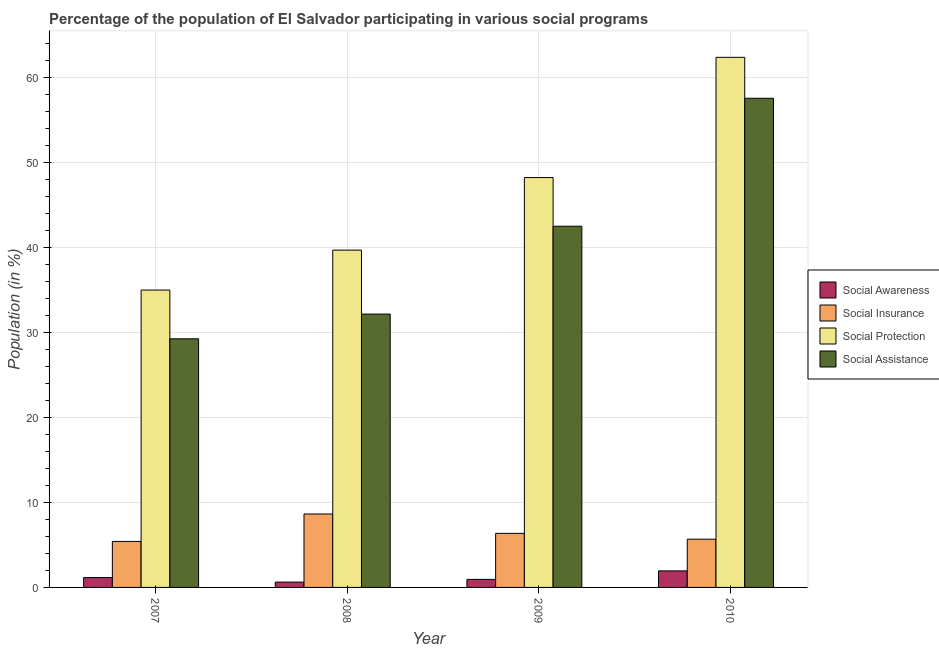How many different coloured bars are there?
Give a very brief answer. 4. How many groups of bars are there?
Give a very brief answer. 4. Are the number of bars per tick equal to the number of legend labels?
Provide a short and direct response. Yes. Are the number of bars on each tick of the X-axis equal?
Your answer should be very brief. Yes. In how many cases, is the number of bars for a given year not equal to the number of legend labels?
Your answer should be very brief. 0. What is the participation of population in social insurance programs in 2008?
Your response must be concise. 8.63. Across all years, what is the maximum participation of population in social protection programs?
Your answer should be compact. 62.34. Across all years, what is the minimum participation of population in social awareness programs?
Offer a very short reply. 0.63. In which year was the participation of population in social insurance programs maximum?
Your response must be concise. 2008. In which year was the participation of population in social insurance programs minimum?
Provide a succinct answer. 2007. What is the total participation of population in social insurance programs in the graph?
Give a very brief answer. 26.07. What is the difference between the participation of population in social insurance programs in 2007 and that in 2010?
Your answer should be very brief. -0.26. What is the difference between the participation of population in social assistance programs in 2009 and the participation of population in social insurance programs in 2007?
Provide a succinct answer. 13.24. What is the average participation of population in social awareness programs per year?
Your response must be concise. 1.17. In the year 2008, what is the difference between the participation of population in social protection programs and participation of population in social awareness programs?
Keep it short and to the point. 0. In how many years, is the participation of population in social protection programs greater than 44 %?
Ensure brevity in your answer.  2. What is the ratio of the participation of population in social protection programs in 2007 to that in 2008?
Ensure brevity in your answer.  0.88. What is the difference between the highest and the second highest participation of population in social awareness programs?
Provide a succinct answer. 0.79. What is the difference between the highest and the lowest participation of population in social awareness programs?
Provide a short and direct response. 1.32. In how many years, is the participation of population in social awareness programs greater than the average participation of population in social awareness programs taken over all years?
Provide a short and direct response. 1. Is the sum of the participation of population in social protection programs in 2008 and 2010 greater than the maximum participation of population in social insurance programs across all years?
Provide a succinct answer. Yes. Is it the case that in every year, the sum of the participation of population in social insurance programs and participation of population in social awareness programs is greater than the sum of participation of population in social protection programs and participation of population in social assistance programs?
Keep it short and to the point. No. What does the 4th bar from the left in 2007 represents?
Ensure brevity in your answer.  Social Assistance. What does the 1st bar from the right in 2007 represents?
Make the answer very short. Social Assistance. Are all the bars in the graph horizontal?
Offer a very short reply. No. How many years are there in the graph?
Keep it short and to the point. 4. What is the difference between two consecutive major ticks on the Y-axis?
Provide a short and direct response. 10. Are the values on the major ticks of Y-axis written in scientific E-notation?
Keep it short and to the point. No. Where does the legend appear in the graph?
Give a very brief answer. Center right. How many legend labels are there?
Keep it short and to the point. 4. How are the legend labels stacked?
Offer a terse response. Vertical. What is the title of the graph?
Your answer should be compact. Percentage of the population of El Salvador participating in various social programs . What is the label or title of the X-axis?
Give a very brief answer. Year. What is the Population (in %) of Social Awareness in 2007?
Your answer should be compact. 1.16. What is the Population (in %) of Social Insurance in 2007?
Make the answer very short. 5.41. What is the Population (in %) in Social Protection in 2007?
Ensure brevity in your answer.  34.97. What is the Population (in %) of Social Assistance in 2007?
Keep it short and to the point. 29.24. What is the Population (in %) in Social Awareness in 2008?
Your response must be concise. 0.63. What is the Population (in %) in Social Insurance in 2008?
Give a very brief answer. 8.63. What is the Population (in %) in Social Protection in 2008?
Provide a short and direct response. 39.67. What is the Population (in %) in Social Assistance in 2008?
Offer a very short reply. 32.15. What is the Population (in %) in Social Awareness in 2009?
Your answer should be compact. 0.95. What is the Population (in %) in Social Insurance in 2009?
Your answer should be compact. 6.36. What is the Population (in %) of Social Protection in 2009?
Provide a short and direct response. 48.2. What is the Population (in %) of Social Assistance in 2009?
Give a very brief answer. 42.48. What is the Population (in %) of Social Awareness in 2010?
Your answer should be very brief. 1.95. What is the Population (in %) in Social Insurance in 2010?
Make the answer very short. 5.67. What is the Population (in %) in Social Protection in 2010?
Provide a succinct answer. 62.34. What is the Population (in %) of Social Assistance in 2010?
Ensure brevity in your answer.  57.53. Across all years, what is the maximum Population (in %) in Social Awareness?
Make the answer very short. 1.95. Across all years, what is the maximum Population (in %) in Social Insurance?
Provide a succinct answer. 8.63. Across all years, what is the maximum Population (in %) of Social Protection?
Provide a succinct answer. 62.34. Across all years, what is the maximum Population (in %) of Social Assistance?
Make the answer very short. 57.53. Across all years, what is the minimum Population (in %) in Social Awareness?
Offer a terse response. 0.63. Across all years, what is the minimum Population (in %) in Social Insurance?
Ensure brevity in your answer.  5.41. Across all years, what is the minimum Population (in %) of Social Protection?
Make the answer very short. 34.97. Across all years, what is the minimum Population (in %) in Social Assistance?
Give a very brief answer. 29.24. What is the total Population (in %) of Social Awareness in the graph?
Keep it short and to the point. 4.68. What is the total Population (in %) in Social Insurance in the graph?
Your answer should be compact. 26.07. What is the total Population (in %) of Social Protection in the graph?
Make the answer very short. 185.18. What is the total Population (in %) in Social Assistance in the graph?
Offer a terse response. 161.39. What is the difference between the Population (in %) in Social Awareness in 2007 and that in 2008?
Provide a succinct answer. 0.53. What is the difference between the Population (in %) of Social Insurance in 2007 and that in 2008?
Your answer should be compact. -3.23. What is the difference between the Population (in %) of Social Protection in 2007 and that in 2008?
Provide a short and direct response. -4.7. What is the difference between the Population (in %) in Social Assistance in 2007 and that in 2008?
Make the answer very short. -2.91. What is the difference between the Population (in %) of Social Awareness in 2007 and that in 2009?
Ensure brevity in your answer.  0.21. What is the difference between the Population (in %) in Social Insurance in 2007 and that in 2009?
Your answer should be compact. -0.95. What is the difference between the Population (in %) in Social Protection in 2007 and that in 2009?
Provide a succinct answer. -13.23. What is the difference between the Population (in %) of Social Assistance in 2007 and that in 2009?
Provide a short and direct response. -13.24. What is the difference between the Population (in %) in Social Awareness in 2007 and that in 2010?
Make the answer very short. -0.79. What is the difference between the Population (in %) in Social Insurance in 2007 and that in 2010?
Give a very brief answer. -0.26. What is the difference between the Population (in %) in Social Protection in 2007 and that in 2010?
Your answer should be compact. -27.37. What is the difference between the Population (in %) in Social Assistance in 2007 and that in 2010?
Your answer should be compact. -28.29. What is the difference between the Population (in %) in Social Awareness in 2008 and that in 2009?
Your answer should be compact. -0.32. What is the difference between the Population (in %) of Social Insurance in 2008 and that in 2009?
Your answer should be compact. 2.28. What is the difference between the Population (in %) of Social Protection in 2008 and that in 2009?
Make the answer very short. -8.53. What is the difference between the Population (in %) of Social Assistance in 2008 and that in 2009?
Keep it short and to the point. -10.33. What is the difference between the Population (in %) in Social Awareness in 2008 and that in 2010?
Give a very brief answer. -1.32. What is the difference between the Population (in %) in Social Insurance in 2008 and that in 2010?
Keep it short and to the point. 2.96. What is the difference between the Population (in %) of Social Protection in 2008 and that in 2010?
Provide a succinct answer. -22.67. What is the difference between the Population (in %) in Social Assistance in 2008 and that in 2010?
Offer a very short reply. -25.38. What is the difference between the Population (in %) in Social Awareness in 2009 and that in 2010?
Give a very brief answer. -1. What is the difference between the Population (in %) of Social Insurance in 2009 and that in 2010?
Ensure brevity in your answer.  0.68. What is the difference between the Population (in %) of Social Protection in 2009 and that in 2010?
Offer a terse response. -14.14. What is the difference between the Population (in %) of Social Assistance in 2009 and that in 2010?
Provide a succinct answer. -15.05. What is the difference between the Population (in %) of Social Awareness in 2007 and the Population (in %) of Social Insurance in 2008?
Provide a short and direct response. -7.48. What is the difference between the Population (in %) of Social Awareness in 2007 and the Population (in %) of Social Protection in 2008?
Give a very brief answer. -38.51. What is the difference between the Population (in %) of Social Awareness in 2007 and the Population (in %) of Social Assistance in 2008?
Give a very brief answer. -30.99. What is the difference between the Population (in %) of Social Insurance in 2007 and the Population (in %) of Social Protection in 2008?
Make the answer very short. -34.26. What is the difference between the Population (in %) of Social Insurance in 2007 and the Population (in %) of Social Assistance in 2008?
Offer a very short reply. -26.74. What is the difference between the Population (in %) of Social Protection in 2007 and the Population (in %) of Social Assistance in 2008?
Ensure brevity in your answer.  2.83. What is the difference between the Population (in %) in Social Awareness in 2007 and the Population (in %) in Social Insurance in 2009?
Your response must be concise. -5.2. What is the difference between the Population (in %) in Social Awareness in 2007 and the Population (in %) in Social Protection in 2009?
Make the answer very short. -47.04. What is the difference between the Population (in %) in Social Awareness in 2007 and the Population (in %) in Social Assistance in 2009?
Provide a short and direct response. -41.32. What is the difference between the Population (in %) in Social Insurance in 2007 and the Population (in %) in Social Protection in 2009?
Keep it short and to the point. -42.79. What is the difference between the Population (in %) in Social Insurance in 2007 and the Population (in %) in Social Assistance in 2009?
Provide a short and direct response. -37.07. What is the difference between the Population (in %) in Social Protection in 2007 and the Population (in %) in Social Assistance in 2009?
Make the answer very short. -7.5. What is the difference between the Population (in %) in Social Awareness in 2007 and the Population (in %) in Social Insurance in 2010?
Ensure brevity in your answer.  -4.51. What is the difference between the Population (in %) in Social Awareness in 2007 and the Population (in %) in Social Protection in 2010?
Your response must be concise. -61.18. What is the difference between the Population (in %) in Social Awareness in 2007 and the Population (in %) in Social Assistance in 2010?
Your answer should be very brief. -56.37. What is the difference between the Population (in %) in Social Insurance in 2007 and the Population (in %) in Social Protection in 2010?
Offer a very short reply. -56.93. What is the difference between the Population (in %) of Social Insurance in 2007 and the Population (in %) of Social Assistance in 2010?
Make the answer very short. -52.12. What is the difference between the Population (in %) of Social Protection in 2007 and the Population (in %) of Social Assistance in 2010?
Your answer should be very brief. -22.55. What is the difference between the Population (in %) of Social Awareness in 2008 and the Population (in %) of Social Insurance in 2009?
Ensure brevity in your answer.  -5.73. What is the difference between the Population (in %) of Social Awareness in 2008 and the Population (in %) of Social Protection in 2009?
Provide a succinct answer. -47.57. What is the difference between the Population (in %) of Social Awareness in 2008 and the Population (in %) of Social Assistance in 2009?
Your answer should be very brief. -41.85. What is the difference between the Population (in %) of Social Insurance in 2008 and the Population (in %) of Social Protection in 2009?
Provide a succinct answer. -39.57. What is the difference between the Population (in %) of Social Insurance in 2008 and the Population (in %) of Social Assistance in 2009?
Give a very brief answer. -33.84. What is the difference between the Population (in %) in Social Protection in 2008 and the Population (in %) in Social Assistance in 2009?
Your response must be concise. -2.81. What is the difference between the Population (in %) of Social Awareness in 2008 and the Population (in %) of Social Insurance in 2010?
Your answer should be very brief. -5.04. What is the difference between the Population (in %) of Social Awareness in 2008 and the Population (in %) of Social Protection in 2010?
Your response must be concise. -61.71. What is the difference between the Population (in %) of Social Awareness in 2008 and the Population (in %) of Social Assistance in 2010?
Provide a short and direct response. -56.9. What is the difference between the Population (in %) in Social Insurance in 2008 and the Population (in %) in Social Protection in 2010?
Provide a short and direct response. -53.71. What is the difference between the Population (in %) of Social Insurance in 2008 and the Population (in %) of Social Assistance in 2010?
Your response must be concise. -48.89. What is the difference between the Population (in %) in Social Protection in 2008 and the Population (in %) in Social Assistance in 2010?
Ensure brevity in your answer.  -17.86. What is the difference between the Population (in %) in Social Awareness in 2009 and the Population (in %) in Social Insurance in 2010?
Give a very brief answer. -4.73. What is the difference between the Population (in %) of Social Awareness in 2009 and the Population (in %) of Social Protection in 2010?
Make the answer very short. -61.4. What is the difference between the Population (in %) in Social Awareness in 2009 and the Population (in %) in Social Assistance in 2010?
Keep it short and to the point. -56.58. What is the difference between the Population (in %) in Social Insurance in 2009 and the Population (in %) in Social Protection in 2010?
Offer a very short reply. -55.98. What is the difference between the Population (in %) in Social Insurance in 2009 and the Population (in %) in Social Assistance in 2010?
Your answer should be very brief. -51.17. What is the difference between the Population (in %) in Social Protection in 2009 and the Population (in %) in Social Assistance in 2010?
Offer a terse response. -9.32. What is the average Population (in %) of Social Awareness per year?
Give a very brief answer. 1.17. What is the average Population (in %) in Social Insurance per year?
Offer a very short reply. 6.52. What is the average Population (in %) in Social Protection per year?
Offer a very short reply. 46.3. What is the average Population (in %) in Social Assistance per year?
Your response must be concise. 40.35. In the year 2007, what is the difference between the Population (in %) in Social Awareness and Population (in %) in Social Insurance?
Offer a terse response. -4.25. In the year 2007, what is the difference between the Population (in %) of Social Awareness and Population (in %) of Social Protection?
Make the answer very short. -33.81. In the year 2007, what is the difference between the Population (in %) of Social Awareness and Population (in %) of Social Assistance?
Make the answer very short. -28.08. In the year 2007, what is the difference between the Population (in %) of Social Insurance and Population (in %) of Social Protection?
Provide a short and direct response. -29.56. In the year 2007, what is the difference between the Population (in %) of Social Insurance and Population (in %) of Social Assistance?
Your response must be concise. -23.83. In the year 2007, what is the difference between the Population (in %) of Social Protection and Population (in %) of Social Assistance?
Offer a terse response. 5.74. In the year 2008, what is the difference between the Population (in %) of Social Awareness and Population (in %) of Social Insurance?
Keep it short and to the point. -8.01. In the year 2008, what is the difference between the Population (in %) of Social Awareness and Population (in %) of Social Protection?
Provide a succinct answer. -39.04. In the year 2008, what is the difference between the Population (in %) of Social Awareness and Population (in %) of Social Assistance?
Offer a very short reply. -31.52. In the year 2008, what is the difference between the Population (in %) of Social Insurance and Population (in %) of Social Protection?
Your answer should be compact. -31.03. In the year 2008, what is the difference between the Population (in %) in Social Insurance and Population (in %) in Social Assistance?
Offer a very short reply. -23.51. In the year 2008, what is the difference between the Population (in %) in Social Protection and Population (in %) in Social Assistance?
Your answer should be compact. 7.52. In the year 2009, what is the difference between the Population (in %) in Social Awareness and Population (in %) in Social Insurance?
Ensure brevity in your answer.  -5.41. In the year 2009, what is the difference between the Population (in %) of Social Awareness and Population (in %) of Social Protection?
Your response must be concise. -47.26. In the year 2009, what is the difference between the Population (in %) of Social Awareness and Population (in %) of Social Assistance?
Keep it short and to the point. -41.53. In the year 2009, what is the difference between the Population (in %) of Social Insurance and Population (in %) of Social Protection?
Your response must be concise. -41.84. In the year 2009, what is the difference between the Population (in %) of Social Insurance and Population (in %) of Social Assistance?
Provide a short and direct response. -36.12. In the year 2009, what is the difference between the Population (in %) of Social Protection and Population (in %) of Social Assistance?
Make the answer very short. 5.72. In the year 2010, what is the difference between the Population (in %) of Social Awareness and Population (in %) of Social Insurance?
Provide a short and direct response. -3.73. In the year 2010, what is the difference between the Population (in %) of Social Awareness and Population (in %) of Social Protection?
Offer a very short reply. -60.39. In the year 2010, what is the difference between the Population (in %) of Social Awareness and Population (in %) of Social Assistance?
Your answer should be compact. -55.58. In the year 2010, what is the difference between the Population (in %) of Social Insurance and Population (in %) of Social Protection?
Your answer should be very brief. -56.67. In the year 2010, what is the difference between the Population (in %) in Social Insurance and Population (in %) in Social Assistance?
Keep it short and to the point. -51.85. In the year 2010, what is the difference between the Population (in %) of Social Protection and Population (in %) of Social Assistance?
Your answer should be compact. 4.82. What is the ratio of the Population (in %) in Social Awareness in 2007 to that in 2008?
Provide a succinct answer. 1.84. What is the ratio of the Population (in %) of Social Insurance in 2007 to that in 2008?
Provide a succinct answer. 0.63. What is the ratio of the Population (in %) of Social Protection in 2007 to that in 2008?
Offer a very short reply. 0.88. What is the ratio of the Population (in %) of Social Assistance in 2007 to that in 2008?
Offer a very short reply. 0.91. What is the ratio of the Population (in %) of Social Awareness in 2007 to that in 2009?
Your answer should be compact. 1.23. What is the ratio of the Population (in %) of Social Insurance in 2007 to that in 2009?
Your answer should be very brief. 0.85. What is the ratio of the Population (in %) in Social Protection in 2007 to that in 2009?
Offer a very short reply. 0.73. What is the ratio of the Population (in %) of Social Assistance in 2007 to that in 2009?
Provide a short and direct response. 0.69. What is the ratio of the Population (in %) of Social Awareness in 2007 to that in 2010?
Keep it short and to the point. 0.6. What is the ratio of the Population (in %) of Social Insurance in 2007 to that in 2010?
Provide a succinct answer. 0.95. What is the ratio of the Population (in %) of Social Protection in 2007 to that in 2010?
Keep it short and to the point. 0.56. What is the ratio of the Population (in %) of Social Assistance in 2007 to that in 2010?
Offer a very short reply. 0.51. What is the ratio of the Population (in %) of Social Awareness in 2008 to that in 2009?
Offer a terse response. 0.67. What is the ratio of the Population (in %) in Social Insurance in 2008 to that in 2009?
Your answer should be very brief. 1.36. What is the ratio of the Population (in %) in Social Protection in 2008 to that in 2009?
Keep it short and to the point. 0.82. What is the ratio of the Population (in %) in Social Assistance in 2008 to that in 2009?
Offer a very short reply. 0.76. What is the ratio of the Population (in %) of Social Awareness in 2008 to that in 2010?
Provide a succinct answer. 0.32. What is the ratio of the Population (in %) in Social Insurance in 2008 to that in 2010?
Provide a succinct answer. 1.52. What is the ratio of the Population (in %) of Social Protection in 2008 to that in 2010?
Offer a very short reply. 0.64. What is the ratio of the Population (in %) in Social Assistance in 2008 to that in 2010?
Ensure brevity in your answer.  0.56. What is the ratio of the Population (in %) in Social Awareness in 2009 to that in 2010?
Keep it short and to the point. 0.49. What is the ratio of the Population (in %) in Social Insurance in 2009 to that in 2010?
Make the answer very short. 1.12. What is the ratio of the Population (in %) of Social Protection in 2009 to that in 2010?
Offer a very short reply. 0.77. What is the ratio of the Population (in %) of Social Assistance in 2009 to that in 2010?
Ensure brevity in your answer.  0.74. What is the difference between the highest and the second highest Population (in %) of Social Awareness?
Your response must be concise. 0.79. What is the difference between the highest and the second highest Population (in %) in Social Insurance?
Your response must be concise. 2.28. What is the difference between the highest and the second highest Population (in %) in Social Protection?
Your answer should be compact. 14.14. What is the difference between the highest and the second highest Population (in %) of Social Assistance?
Your answer should be compact. 15.05. What is the difference between the highest and the lowest Population (in %) of Social Awareness?
Offer a very short reply. 1.32. What is the difference between the highest and the lowest Population (in %) in Social Insurance?
Provide a succinct answer. 3.23. What is the difference between the highest and the lowest Population (in %) of Social Protection?
Offer a terse response. 27.37. What is the difference between the highest and the lowest Population (in %) of Social Assistance?
Give a very brief answer. 28.29. 